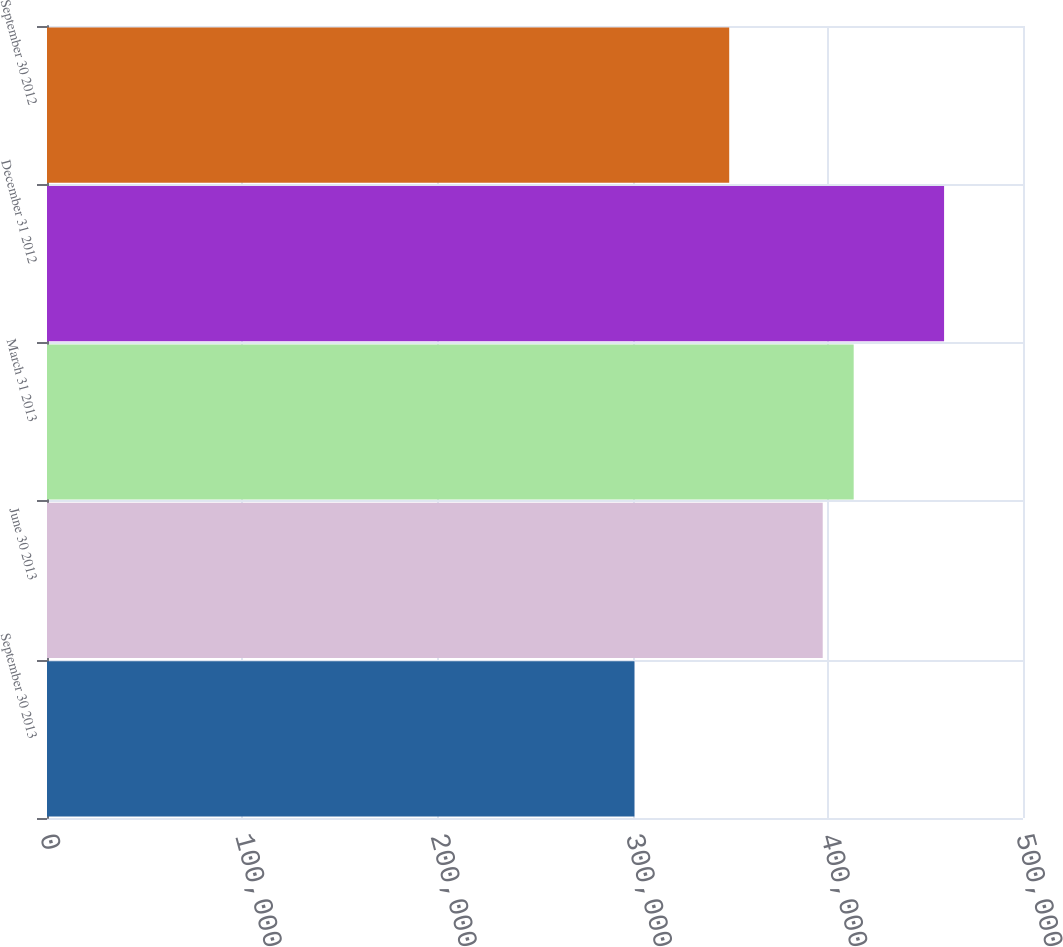<chart> <loc_0><loc_0><loc_500><loc_500><bar_chart><fcel>September 30 2013<fcel>June 30 2013<fcel>March 31 2013<fcel>December 31 2012<fcel>September 30 2012<nl><fcel>300933<fcel>397398<fcel>413261<fcel>459567<fcel>349495<nl></chart> 